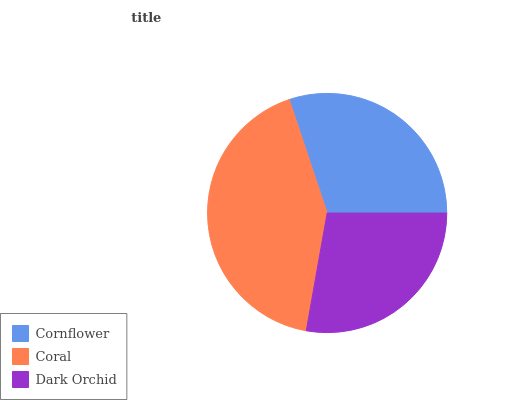Is Dark Orchid the minimum?
Answer yes or no. Yes. Is Coral the maximum?
Answer yes or no. Yes. Is Coral the minimum?
Answer yes or no. No. Is Dark Orchid the maximum?
Answer yes or no. No. Is Coral greater than Dark Orchid?
Answer yes or no. Yes. Is Dark Orchid less than Coral?
Answer yes or no. Yes. Is Dark Orchid greater than Coral?
Answer yes or no. No. Is Coral less than Dark Orchid?
Answer yes or no. No. Is Cornflower the high median?
Answer yes or no. Yes. Is Cornflower the low median?
Answer yes or no. Yes. Is Dark Orchid the high median?
Answer yes or no. No. Is Dark Orchid the low median?
Answer yes or no. No. 